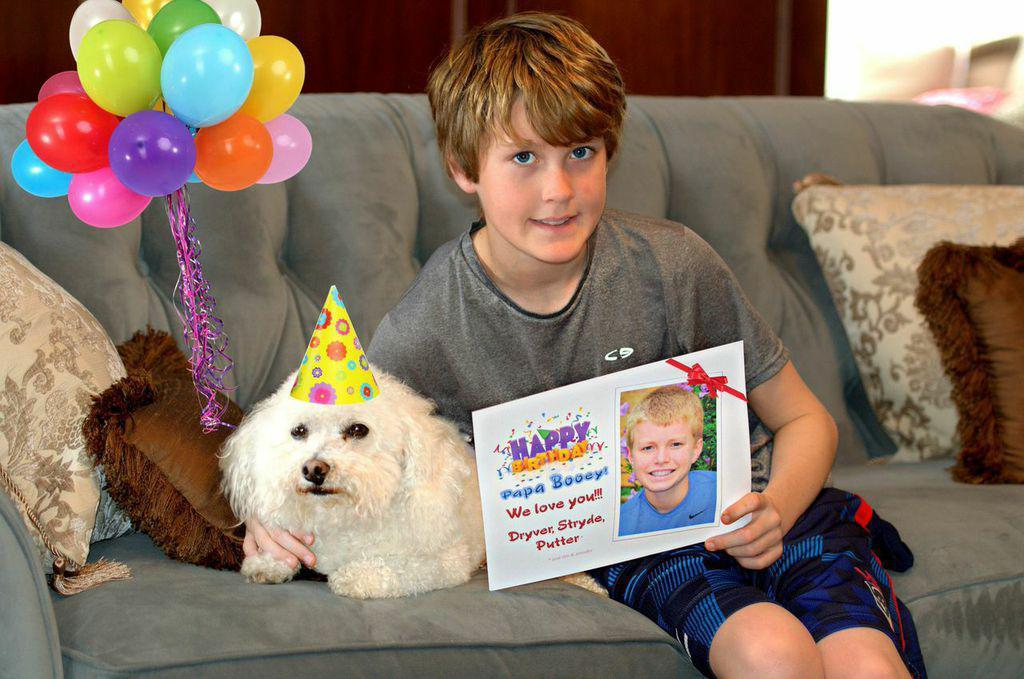Who is the main subject in the image? There is a boy in the image. What is the boy holding in the image? The boy is holding a greeting card. Where is the boy sitting in the image? The boy is sitting on a sofa. What is on the second sofa in the image? There is a cap on the head of the second sofa. What type of soft furnishings can be seen in the image? There are pillows in the image. What decorative items are present in the image? There are balloons in the image. What is the boy's brother doing in the middle of the image? There is no brother present in the image, and the boy is not depicted as doing anything in the middle of the image. 